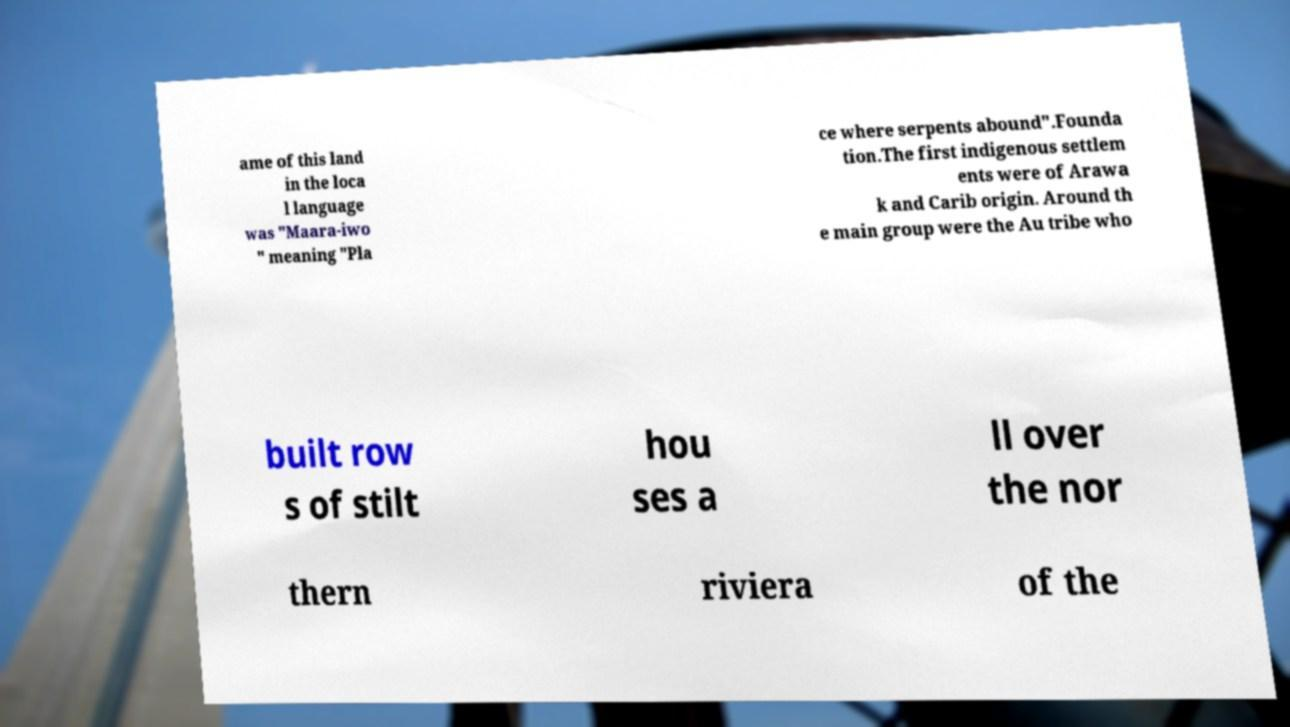For documentation purposes, I need the text within this image transcribed. Could you provide that? ame of this land in the loca l language was "Maara-iwo " meaning "Pla ce where serpents abound".Founda tion.The first indigenous settlem ents were of Arawa k and Carib origin. Around th e main group were the Au tribe who built row s of stilt hou ses a ll over the nor thern riviera of the 